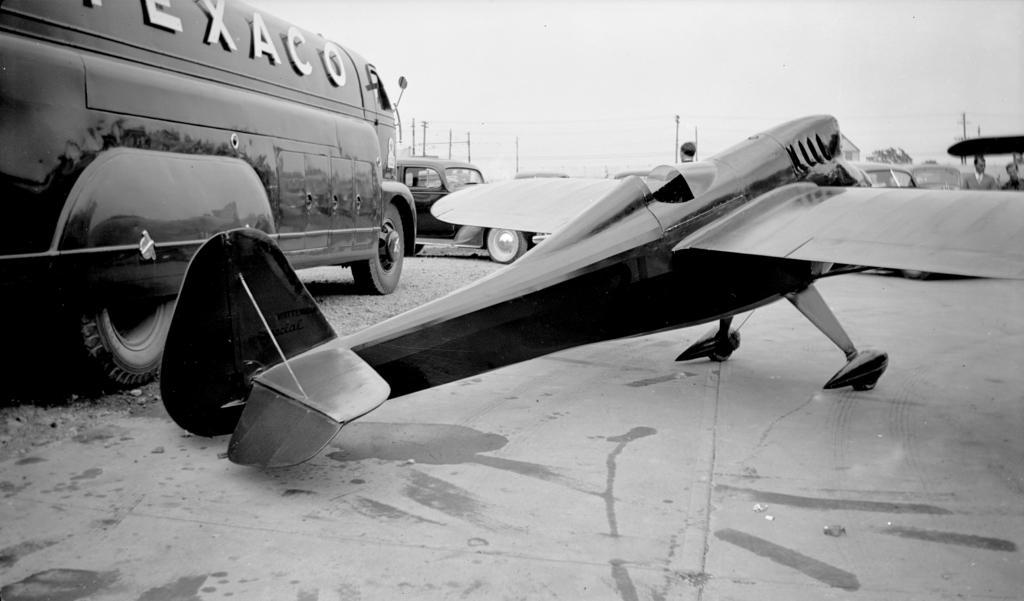Could you give a brief overview of what you see in this image? This is black and white picture where we can see chopper, van and cars. Background of the image poles and wires are present. Behind the chopper persons are there. 